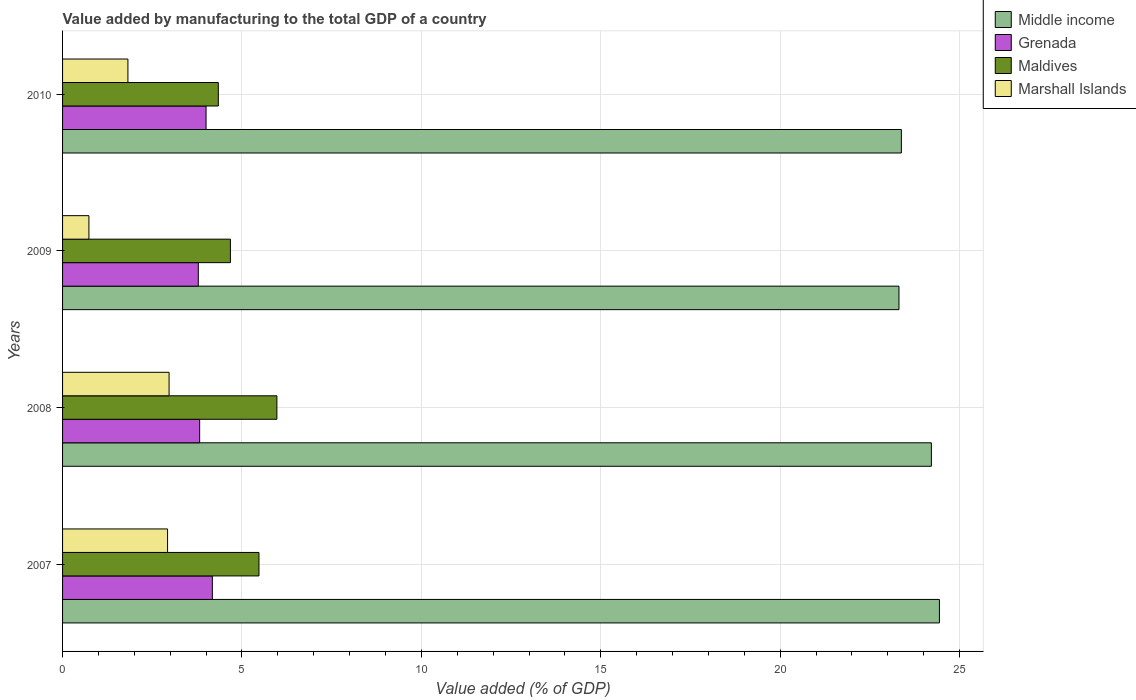Are the number of bars per tick equal to the number of legend labels?
Make the answer very short. Yes. Are the number of bars on each tick of the Y-axis equal?
Offer a terse response. Yes. What is the label of the 2nd group of bars from the top?
Provide a short and direct response. 2009. What is the value added by manufacturing to the total GDP in Grenada in 2008?
Ensure brevity in your answer.  3.82. Across all years, what is the maximum value added by manufacturing to the total GDP in Middle income?
Provide a short and direct response. 24.44. Across all years, what is the minimum value added by manufacturing to the total GDP in Maldives?
Make the answer very short. 4.34. In which year was the value added by manufacturing to the total GDP in Grenada maximum?
Provide a short and direct response. 2007. In which year was the value added by manufacturing to the total GDP in Grenada minimum?
Offer a very short reply. 2009. What is the total value added by manufacturing to the total GDP in Marshall Islands in the graph?
Provide a succinct answer. 8.45. What is the difference between the value added by manufacturing to the total GDP in Maldives in 2008 and that in 2010?
Ensure brevity in your answer.  1.63. What is the difference between the value added by manufacturing to the total GDP in Grenada in 2010 and the value added by manufacturing to the total GDP in Maldives in 2008?
Offer a very short reply. -1.97. What is the average value added by manufacturing to the total GDP in Marshall Islands per year?
Your answer should be very brief. 2.11. In the year 2008, what is the difference between the value added by manufacturing to the total GDP in Middle income and value added by manufacturing to the total GDP in Maldives?
Your response must be concise. 18.24. In how many years, is the value added by manufacturing to the total GDP in Maldives greater than 4 %?
Your response must be concise. 4. What is the ratio of the value added by manufacturing to the total GDP in Maldives in 2007 to that in 2008?
Provide a short and direct response. 0.92. Is the value added by manufacturing to the total GDP in Marshall Islands in 2007 less than that in 2010?
Make the answer very short. No. What is the difference between the highest and the second highest value added by manufacturing to the total GDP in Middle income?
Make the answer very short. 0.22. What is the difference between the highest and the lowest value added by manufacturing to the total GDP in Grenada?
Make the answer very short. 0.39. In how many years, is the value added by manufacturing to the total GDP in Maldives greater than the average value added by manufacturing to the total GDP in Maldives taken over all years?
Provide a short and direct response. 2. Is it the case that in every year, the sum of the value added by manufacturing to the total GDP in Marshall Islands and value added by manufacturing to the total GDP in Middle income is greater than the sum of value added by manufacturing to the total GDP in Maldives and value added by manufacturing to the total GDP in Grenada?
Ensure brevity in your answer.  Yes. What does the 1st bar from the top in 2010 represents?
Make the answer very short. Marshall Islands. What does the 3rd bar from the bottom in 2010 represents?
Make the answer very short. Maldives. Is it the case that in every year, the sum of the value added by manufacturing to the total GDP in Middle income and value added by manufacturing to the total GDP in Grenada is greater than the value added by manufacturing to the total GDP in Maldives?
Your answer should be very brief. Yes. Are all the bars in the graph horizontal?
Provide a short and direct response. Yes. Are the values on the major ticks of X-axis written in scientific E-notation?
Your response must be concise. No. Does the graph contain any zero values?
Make the answer very short. No. How are the legend labels stacked?
Your answer should be compact. Vertical. What is the title of the graph?
Your response must be concise. Value added by manufacturing to the total GDP of a country. Does "Brunei Darussalam" appear as one of the legend labels in the graph?
Your answer should be very brief. No. What is the label or title of the X-axis?
Give a very brief answer. Value added (% of GDP). What is the label or title of the Y-axis?
Provide a short and direct response. Years. What is the Value added (% of GDP) of Middle income in 2007?
Ensure brevity in your answer.  24.44. What is the Value added (% of GDP) of Grenada in 2007?
Your answer should be compact. 4.17. What is the Value added (% of GDP) in Maldives in 2007?
Give a very brief answer. 5.47. What is the Value added (% of GDP) of Marshall Islands in 2007?
Ensure brevity in your answer.  2.93. What is the Value added (% of GDP) in Middle income in 2008?
Offer a terse response. 24.21. What is the Value added (% of GDP) in Grenada in 2008?
Ensure brevity in your answer.  3.82. What is the Value added (% of GDP) in Maldives in 2008?
Your response must be concise. 5.97. What is the Value added (% of GDP) of Marshall Islands in 2008?
Provide a succinct answer. 2.97. What is the Value added (% of GDP) in Middle income in 2009?
Provide a short and direct response. 23.31. What is the Value added (% of GDP) of Grenada in 2009?
Keep it short and to the point. 3.78. What is the Value added (% of GDP) in Maldives in 2009?
Offer a terse response. 4.68. What is the Value added (% of GDP) of Marshall Islands in 2009?
Your answer should be compact. 0.73. What is the Value added (% of GDP) of Middle income in 2010?
Make the answer very short. 23.38. What is the Value added (% of GDP) in Grenada in 2010?
Offer a terse response. 4. What is the Value added (% of GDP) of Maldives in 2010?
Offer a very short reply. 4.34. What is the Value added (% of GDP) of Marshall Islands in 2010?
Give a very brief answer. 1.82. Across all years, what is the maximum Value added (% of GDP) in Middle income?
Your answer should be very brief. 24.44. Across all years, what is the maximum Value added (% of GDP) of Grenada?
Provide a short and direct response. 4.17. Across all years, what is the maximum Value added (% of GDP) of Maldives?
Your answer should be very brief. 5.97. Across all years, what is the maximum Value added (% of GDP) in Marshall Islands?
Offer a terse response. 2.97. Across all years, what is the minimum Value added (% of GDP) in Middle income?
Provide a short and direct response. 23.31. Across all years, what is the minimum Value added (% of GDP) in Grenada?
Ensure brevity in your answer.  3.78. Across all years, what is the minimum Value added (% of GDP) in Maldives?
Provide a succinct answer. 4.34. Across all years, what is the minimum Value added (% of GDP) in Marshall Islands?
Offer a terse response. 0.73. What is the total Value added (% of GDP) of Middle income in the graph?
Your answer should be compact. 95.34. What is the total Value added (% of GDP) of Grenada in the graph?
Make the answer very short. 15.78. What is the total Value added (% of GDP) of Maldives in the graph?
Make the answer very short. 20.47. What is the total Value added (% of GDP) of Marshall Islands in the graph?
Provide a succinct answer. 8.45. What is the difference between the Value added (% of GDP) of Middle income in 2007 and that in 2008?
Make the answer very short. 0.22. What is the difference between the Value added (% of GDP) in Grenada in 2007 and that in 2008?
Your response must be concise. 0.35. What is the difference between the Value added (% of GDP) in Maldives in 2007 and that in 2008?
Keep it short and to the point. -0.5. What is the difference between the Value added (% of GDP) of Marshall Islands in 2007 and that in 2008?
Ensure brevity in your answer.  -0.04. What is the difference between the Value added (% of GDP) in Middle income in 2007 and that in 2009?
Keep it short and to the point. 1.13. What is the difference between the Value added (% of GDP) in Grenada in 2007 and that in 2009?
Ensure brevity in your answer.  0.39. What is the difference between the Value added (% of GDP) in Maldives in 2007 and that in 2009?
Give a very brief answer. 0.8. What is the difference between the Value added (% of GDP) in Marshall Islands in 2007 and that in 2009?
Your answer should be very brief. 2.19. What is the difference between the Value added (% of GDP) in Middle income in 2007 and that in 2010?
Offer a very short reply. 1.06. What is the difference between the Value added (% of GDP) of Grenada in 2007 and that in 2010?
Provide a succinct answer. 0.18. What is the difference between the Value added (% of GDP) of Maldives in 2007 and that in 2010?
Your answer should be very brief. 1.13. What is the difference between the Value added (% of GDP) of Marshall Islands in 2007 and that in 2010?
Provide a short and direct response. 1.1. What is the difference between the Value added (% of GDP) of Middle income in 2008 and that in 2009?
Your answer should be compact. 0.9. What is the difference between the Value added (% of GDP) in Grenada in 2008 and that in 2009?
Provide a succinct answer. 0.04. What is the difference between the Value added (% of GDP) of Maldives in 2008 and that in 2009?
Your answer should be compact. 1.3. What is the difference between the Value added (% of GDP) in Marshall Islands in 2008 and that in 2009?
Ensure brevity in your answer.  2.23. What is the difference between the Value added (% of GDP) of Middle income in 2008 and that in 2010?
Offer a very short reply. 0.84. What is the difference between the Value added (% of GDP) in Grenada in 2008 and that in 2010?
Provide a succinct answer. -0.18. What is the difference between the Value added (% of GDP) of Maldives in 2008 and that in 2010?
Provide a succinct answer. 1.63. What is the difference between the Value added (% of GDP) of Marshall Islands in 2008 and that in 2010?
Your response must be concise. 1.15. What is the difference between the Value added (% of GDP) in Middle income in 2009 and that in 2010?
Your answer should be compact. -0.07. What is the difference between the Value added (% of GDP) of Grenada in 2009 and that in 2010?
Ensure brevity in your answer.  -0.22. What is the difference between the Value added (% of GDP) of Maldives in 2009 and that in 2010?
Ensure brevity in your answer.  0.34. What is the difference between the Value added (% of GDP) in Marshall Islands in 2009 and that in 2010?
Keep it short and to the point. -1.09. What is the difference between the Value added (% of GDP) in Middle income in 2007 and the Value added (% of GDP) in Grenada in 2008?
Keep it short and to the point. 20.62. What is the difference between the Value added (% of GDP) of Middle income in 2007 and the Value added (% of GDP) of Maldives in 2008?
Give a very brief answer. 18.46. What is the difference between the Value added (% of GDP) in Middle income in 2007 and the Value added (% of GDP) in Marshall Islands in 2008?
Provide a short and direct response. 21.47. What is the difference between the Value added (% of GDP) in Grenada in 2007 and the Value added (% of GDP) in Maldives in 2008?
Provide a short and direct response. -1.8. What is the difference between the Value added (% of GDP) in Grenada in 2007 and the Value added (% of GDP) in Marshall Islands in 2008?
Give a very brief answer. 1.21. What is the difference between the Value added (% of GDP) of Maldives in 2007 and the Value added (% of GDP) of Marshall Islands in 2008?
Your answer should be very brief. 2.51. What is the difference between the Value added (% of GDP) in Middle income in 2007 and the Value added (% of GDP) in Grenada in 2009?
Keep it short and to the point. 20.66. What is the difference between the Value added (% of GDP) of Middle income in 2007 and the Value added (% of GDP) of Maldives in 2009?
Ensure brevity in your answer.  19.76. What is the difference between the Value added (% of GDP) in Middle income in 2007 and the Value added (% of GDP) in Marshall Islands in 2009?
Provide a succinct answer. 23.7. What is the difference between the Value added (% of GDP) of Grenada in 2007 and the Value added (% of GDP) of Maldives in 2009?
Keep it short and to the point. -0.5. What is the difference between the Value added (% of GDP) in Grenada in 2007 and the Value added (% of GDP) in Marshall Islands in 2009?
Your response must be concise. 3.44. What is the difference between the Value added (% of GDP) in Maldives in 2007 and the Value added (% of GDP) in Marshall Islands in 2009?
Your answer should be very brief. 4.74. What is the difference between the Value added (% of GDP) of Middle income in 2007 and the Value added (% of GDP) of Grenada in 2010?
Your response must be concise. 20.44. What is the difference between the Value added (% of GDP) of Middle income in 2007 and the Value added (% of GDP) of Maldives in 2010?
Ensure brevity in your answer.  20.1. What is the difference between the Value added (% of GDP) in Middle income in 2007 and the Value added (% of GDP) in Marshall Islands in 2010?
Offer a very short reply. 22.62. What is the difference between the Value added (% of GDP) of Grenada in 2007 and the Value added (% of GDP) of Maldives in 2010?
Ensure brevity in your answer.  -0.17. What is the difference between the Value added (% of GDP) in Grenada in 2007 and the Value added (% of GDP) in Marshall Islands in 2010?
Make the answer very short. 2.35. What is the difference between the Value added (% of GDP) of Maldives in 2007 and the Value added (% of GDP) of Marshall Islands in 2010?
Offer a terse response. 3.65. What is the difference between the Value added (% of GDP) in Middle income in 2008 and the Value added (% of GDP) in Grenada in 2009?
Make the answer very short. 20.43. What is the difference between the Value added (% of GDP) of Middle income in 2008 and the Value added (% of GDP) of Maldives in 2009?
Provide a short and direct response. 19.54. What is the difference between the Value added (% of GDP) of Middle income in 2008 and the Value added (% of GDP) of Marshall Islands in 2009?
Make the answer very short. 23.48. What is the difference between the Value added (% of GDP) of Grenada in 2008 and the Value added (% of GDP) of Maldives in 2009?
Keep it short and to the point. -0.86. What is the difference between the Value added (% of GDP) in Grenada in 2008 and the Value added (% of GDP) in Marshall Islands in 2009?
Keep it short and to the point. 3.09. What is the difference between the Value added (% of GDP) in Maldives in 2008 and the Value added (% of GDP) in Marshall Islands in 2009?
Your answer should be very brief. 5.24. What is the difference between the Value added (% of GDP) in Middle income in 2008 and the Value added (% of GDP) in Grenada in 2010?
Offer a very short reply. 20.21. What is the difference between the Value added (% of GDP) in Middle income in 2008 and the Value added (% of GDP) in Maldives in 2010?
Ensure brevity in your answer.  19.87. What is the difference between the Value added (% of GDP) in Middle income in 2008 and the Value added (% of GDP) in Marshall Islands in 2010?
Ensure brevity in your answer.  22.39. What is the difference between the Value added (% of GDP) of Grenada in 2008 and the Value added (% of GDP) of Maldives in 2010?
Provide a succinct answer. -0.52. What is the difference between the Value added (% of GDP) in Grenada in 2008 and the Value added (% of GDP) in Marshall Islands in 2010?
Your response must be concise. 2. What is the difference between the Value added (% of GDP) in Maldives in 2008 and the Value added (% of GDP) in Marshall Islands in 2010?
Provide a short and direct response. 4.15. What is the difference between the Value added (% of GDP) of Middle income in 2009 and the Value added (% of GDP) of Grenada in 2010?
Your answer should be compact. 19.31. What is the difference between the Value added (% of GDP) of Middle income in 2009 and the Value added (% of GDP) of Maldives in 2010?
Make the answer very short. 18.97. What is the difference between the Value added (% of GDP) in Middle income in 2009 and the Value added (% of GDP) in Marshall Islands in 2010?
Provide a short and direct response. 21.49. What is the difference between the Value added (% of GDP) of Grenada in 2009 and the Value added (% of GDP) of Maldives in 2010?
Offer a very short reply. -0.56. What is the difference between the Value added (% of GDP) in Grenada in 2009 and the Value added (% of GDP) in Marshall Islands in 2010?
Your response must be concise. 1.96. What is the difference between the Value added (% of GDP) of Maldives in 2009 and the Value added (% of GDP) of Marshall Islands in 2010?
Ensure brevity in your answer.  2.86. What is the average Value added (% of GDP) in Middle income per year?
Keep it short and to the point. 23.84. What is the average Value added (% of GDP) in Grenada per year?
Provide a succinct answer. 3.94. What is the average Value added (% of GDP) in Maldives per year?
Offer a terse response. 5.12. What is the average Value added (% of GDP) of Marshall Islands per year?
Provide a succinct answer. 2.11. In the year 2007, what is the difference between the Value added (% of GDP) in Middle income and Value added (% of GDP) in Grenada?
Offer a very short reply. 20.26. In the year 2007, what is the difference between the Value added (% of GDP) of Middle income and Value added (% of GDP) of Maldives?
Keep it short and to the point. 18.96. In the year 2007, what is the difference between the Value added (% of GDP) of Middle income and Value added (% of GDP) of Marshall Islands?
Make the answer very short. 21.51. In the year 2007, what is the difference between the Value added (% of GDP) in Grenada and Value added (% of GDP) in Maldives?
Your answer should be very brief. -1.3. In the year 2007, what is the difference between the Value added (% of GDP) in Grenada and Value added (% of GDP) in Marshall Islands?
Offer a terse response. 1.25. In the year 2007, what is the difference between the Value added (% of GDP) of Maldives and Value added (% of GDP) of Marshall Islands?
Your answer should be very brief. 2.55. In the year 2008, what is the difference between the Value added (% of GDP) in Middle income and Value added (% of GDP) in Grenada?
Offer a terse response. 20.39. In the year 2008, what is the difference between the Value added (% of GDP) in Middle income and Value added (% of GDP) in Maldives?
Give a very brief answer. 18.24. In the year 2008, what is the difference between the Value added (% of GDP) of Middle income and Value added (% of GDP) of Marshall Islands?
Your answer should be very brief. 21.25. In the year 2008, what is the difference between the Value added (% of GDP) in Grenada and Value added (% of GDP) in Maldives?
Ensure brevity in your answer.  -2.15. In the year 2008, what is the difference between the Value added (% of GDP) in Grenada and Value added (% of GDP) in Marshall Islands?
Offer a very short reply. 0.85. In the year 2008, what is the difference between the Value added (% of GDP) of Maldives and Value added (% of GDP) of Marshall Islands?
Offer a very short reply. 3. In the year 2009, what is the difference between the Value added (% of GDP) of Middle income and Value added (% of GDP) of Grenada?
Your answer should be very brief. 19.53. In the year 2009, what is the difference between the Value added (% of GDP) in Middle income and Value added (% of GDP) in Maldives?
Offer a terse response. 18.63. In the year 2009, what is the difference between the Value added (% of GDP) in Middle income and Value added (% of GDP) in Marshall Islands?
Your response must be concise. 22.58. In the year 2009, what is the difference between the Value added (% of GDP) of Grenada and Value added (% of GDP) of Maldives?
Ensure brevity in your answer.  -0.89. In the year 2009, what is the difference between the Value added (% of GDP) in Grenada and Value added (% of GDP) in Marshall Islands?
Your answer should be very brief. 3.05. In the year 2009, what is the difference between the Value added (% of GDP) of Maldives and Value added (% of GDP) of Marshall Islands?
Provide a succinct answer. 3.94. In the year 2010, what is the difference between the Value added (% of GDP) of Middle income and Value added (% of GDP) of Grenada?
Give a very brief answer. 19.38. In the year 2010, what is the difference between the Value added (% of GDP) of Middle income and Value added (% of GDP) of Maldives?
Give a very brief answer. 19.04. In the year 2010, what is the difference between the Value added (% of GDP) in Middle income and Value added (% of GDP) in Marshall Islands?
Keep it short and to the point. 21.56. In the year 2010, what is the difference between the Value added (% of GDP) of Grenada and Value added (% of GDP) of Maldives?
Give a very brief answer. -0.34. In the year 2010, what is the difference between the Value added (% of GDP) of Grenada and Value added (% of GDP) of Marshall Islands?
Provide a short and direct response. 2.18. In the year 2010, what is the difference between the Value added (% of GDP) of Maldives and Value added (% of GDP) of Marshall Islands?
Provide a succinct answer. 2.52. What is the ratio of the Value added (% of GDP) in Middle income in 2007 to that in 2008?
Your answer should be compact. 1.01. What is the ratio of the Value added (% of GDP) of Grenada in 2007 to that in 2008?
Your response must be concise. 1.09. What is the ratio of the Value added (% of GDP) of Maldives in 2007 to that in 2008?
Your response must be concise. 0.92. What is the ratio of the Value added (% of GDP) in Marshall Islands in 2007 to that in 2008?
Offer a terse response. 0.99. What is the ratio of the Value added (% of GDP) in Middle income in 2007 to that in 2009?
Your answer should be very brief. 1.05. What is the ratio of the Value added (% of GDP) of Grenada in 2007 to that in 2009?
Provide a short and direct response. 1.1. What is the ratio of the Value added (% of GDP) of Maldives in 2007 to that in 2009?
Offer a terse response. 1.17. What is the ratio of the Value added (% of GDP) of Marshall Islands in 2007 to that in 2009?
Your answer should be very brief. 3.98. What is the ratio of the Value added (% of GDP) of Middle income in 2007 to that in 2010?
Provide a succinct answer. 1.05. What is the ratio of the Value added (% of GDP) in Grenada in 2007 to that in 2010?
Your answer should be compact. 1.04. What is the ratio of the Value added (% of GDP) in Maldives in 2007 to that in 2010?
Offer a terse response. 1.26. What is the ratio of the Value added (% of GDP) of Marshall Islands in 2007 to that in 2010?
Provide a short and direct response. 1.61. What is the ratio of the Value added (% of GDP) of Middle income in 2008 to that in 2009?
Your answer should be very brief. 1.04. What is the ratio of the Value added (% of GDP) in Grenada in 2008 to that in 2009?
Ensure brevity in your answer.  1.01. What is the ratio of the Value added (% of GDP) of Maldives in 2008 to that in 2009?
Give a very brief answer. 1.28. What is the ratio of the Value added (% of GDP) of Marshall Islands in 2008 to that in 2009?
Provide a succinct answer. 4.04. What is the ratio of the Value added (% of GDP) of Middle income in 2008 to that in 2010?
Offer a very short reply. 1.04. What is the ratio of the Value added (% of GDP) in Grenada in 2008 to that in 2010?
Offer a very short reply. 0.96. What is the ratio of the Value added (% of GDP) of Maldives in 2008 to that in 2010?
Your response must be concise. 1.38. What is the ratio of the Value added (% of GDP) in Marshall Islands in 2008 to that in 2010?
Keep it short and to the point. 1.63. What is the ratio of the Value added (% of GDP) in Grenada in 2009 to that in 2010?
Provide a succinct answer. 0.95. What is the ratio of the Value added (% of GDP) of Maldives in 2009 to that in 2010?
Your answer should be very brief. 1.08. What is the ratio of the Value added (% of GDP) of Marshall Islands in 2009 to that in 2010?
Provide a succinct answer. 0.4. What is the difference between the highest and the second highest Value added (% of GDP) of Middle income?
Provide a succinct answer. 0.22. What is the difference between the highest and the second highest Value added (% of GDP) in Grenada?
Make the answer very short. 0.18. What is the difference between the highest and the second highest Value added (% of GDP) of Maldives?
Offer a terse response. 0.5. What is the difference between the highest and the second highest Value added (% of GDP) in Marshall Islands?
Offer a very short reply. 0.04. What is the difference between the highest and the lowest Value added (% of GDP) in Middle income?
Offer a terse response. 1.13. What is the difference between the highest and the lowest Value added (% of GDP) of Grenada?
Give a very brief answer. 0.39. What is the difference between the highest and the lowest Value added (% of GDP) in Maldives?
Your answer should be compact. 1.63. What is the difference between the highest and the lowest Value added (% of GDP) in Marshall Islands?
Provide a short and direct response. 2.23. 